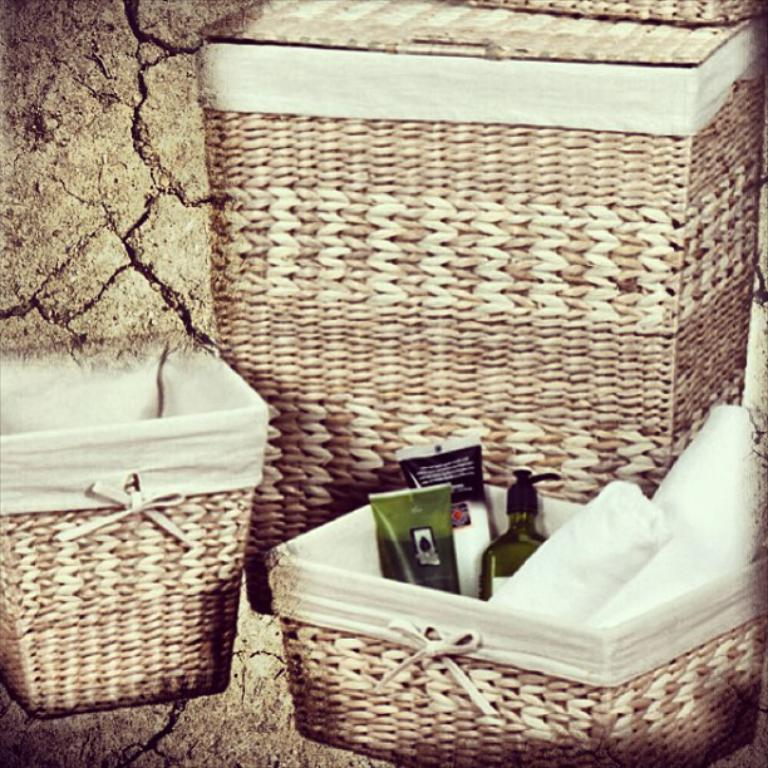What type of containers are present in the image? There are baskets in the image. What else can be seen in the image besides the baskets? There are bottles in the image. What is inside the baskets? There are objects inside the baskets. What is the color of the background in the image? The background color is brown. What opinions do the friends in the image have about the blade? There are no friends or opinions about a blade present in the image. 